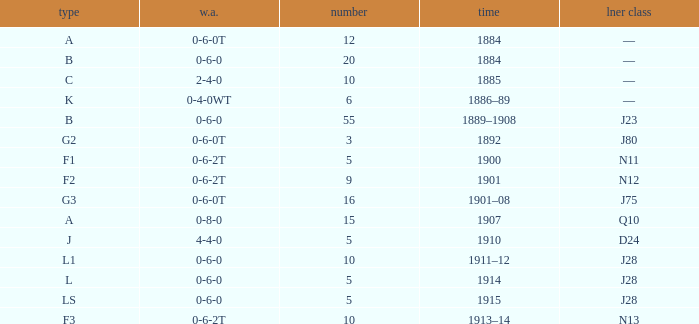What WA has a LNER Class of n13 and 10? 0-6-2T. Would you mind parsing the complete table? {'header': ['type', 'w.a.', 'number', 'time', 'lner class'], 'rows': [['A', '0-6-0T', '12', '1884', '—'], ['B', '0-6-0', '20', '1884', '—'], ['C', '2-4-0', '10', '1885', '—'], ['K', '0-4-0WT', '6', '1886–89', '—'], ['B', '0-6-0', '55', '1889–1908', 'J23'], ['G2', '0-6-0T', '3', '1892', 'J80'], ['F1', '0-6-2T', '5', '1900', 'N11'], ['F2', '0-6-2T', '9', '1901', 'N12'], ['G3', '0-6-0T', '16', '1901–08', 'J75'], ['A', '0-8-0', '15', '1907', 'Q10'], ['J', '4-4-0', '5', '1910', 'D24'], ['L1', '0-6-0', '10', '1911–12', 'J28'], ['L', '0-6-0', '5', '1914', 'J28'], ['LS', '0-6-0', '5', '1915', 'J28'], ['F3', '0-6-2T', '10', '1913–14', 'N13']]} 